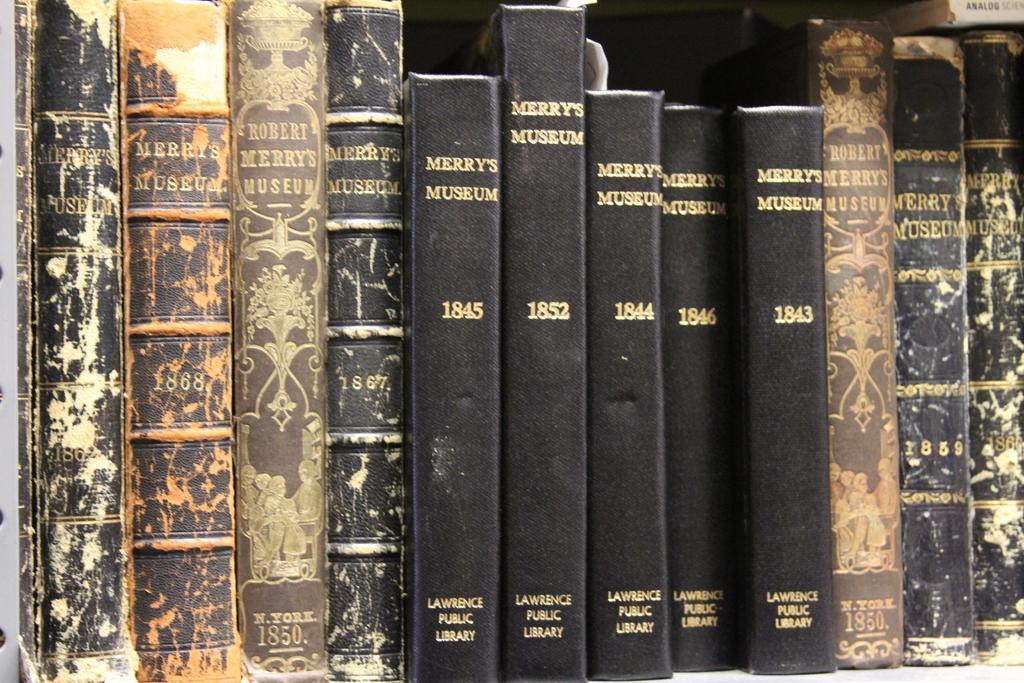Can you describe this image briefly? In this picture we can see many black and brown book spines in a bookshelf with some text printed on them. 